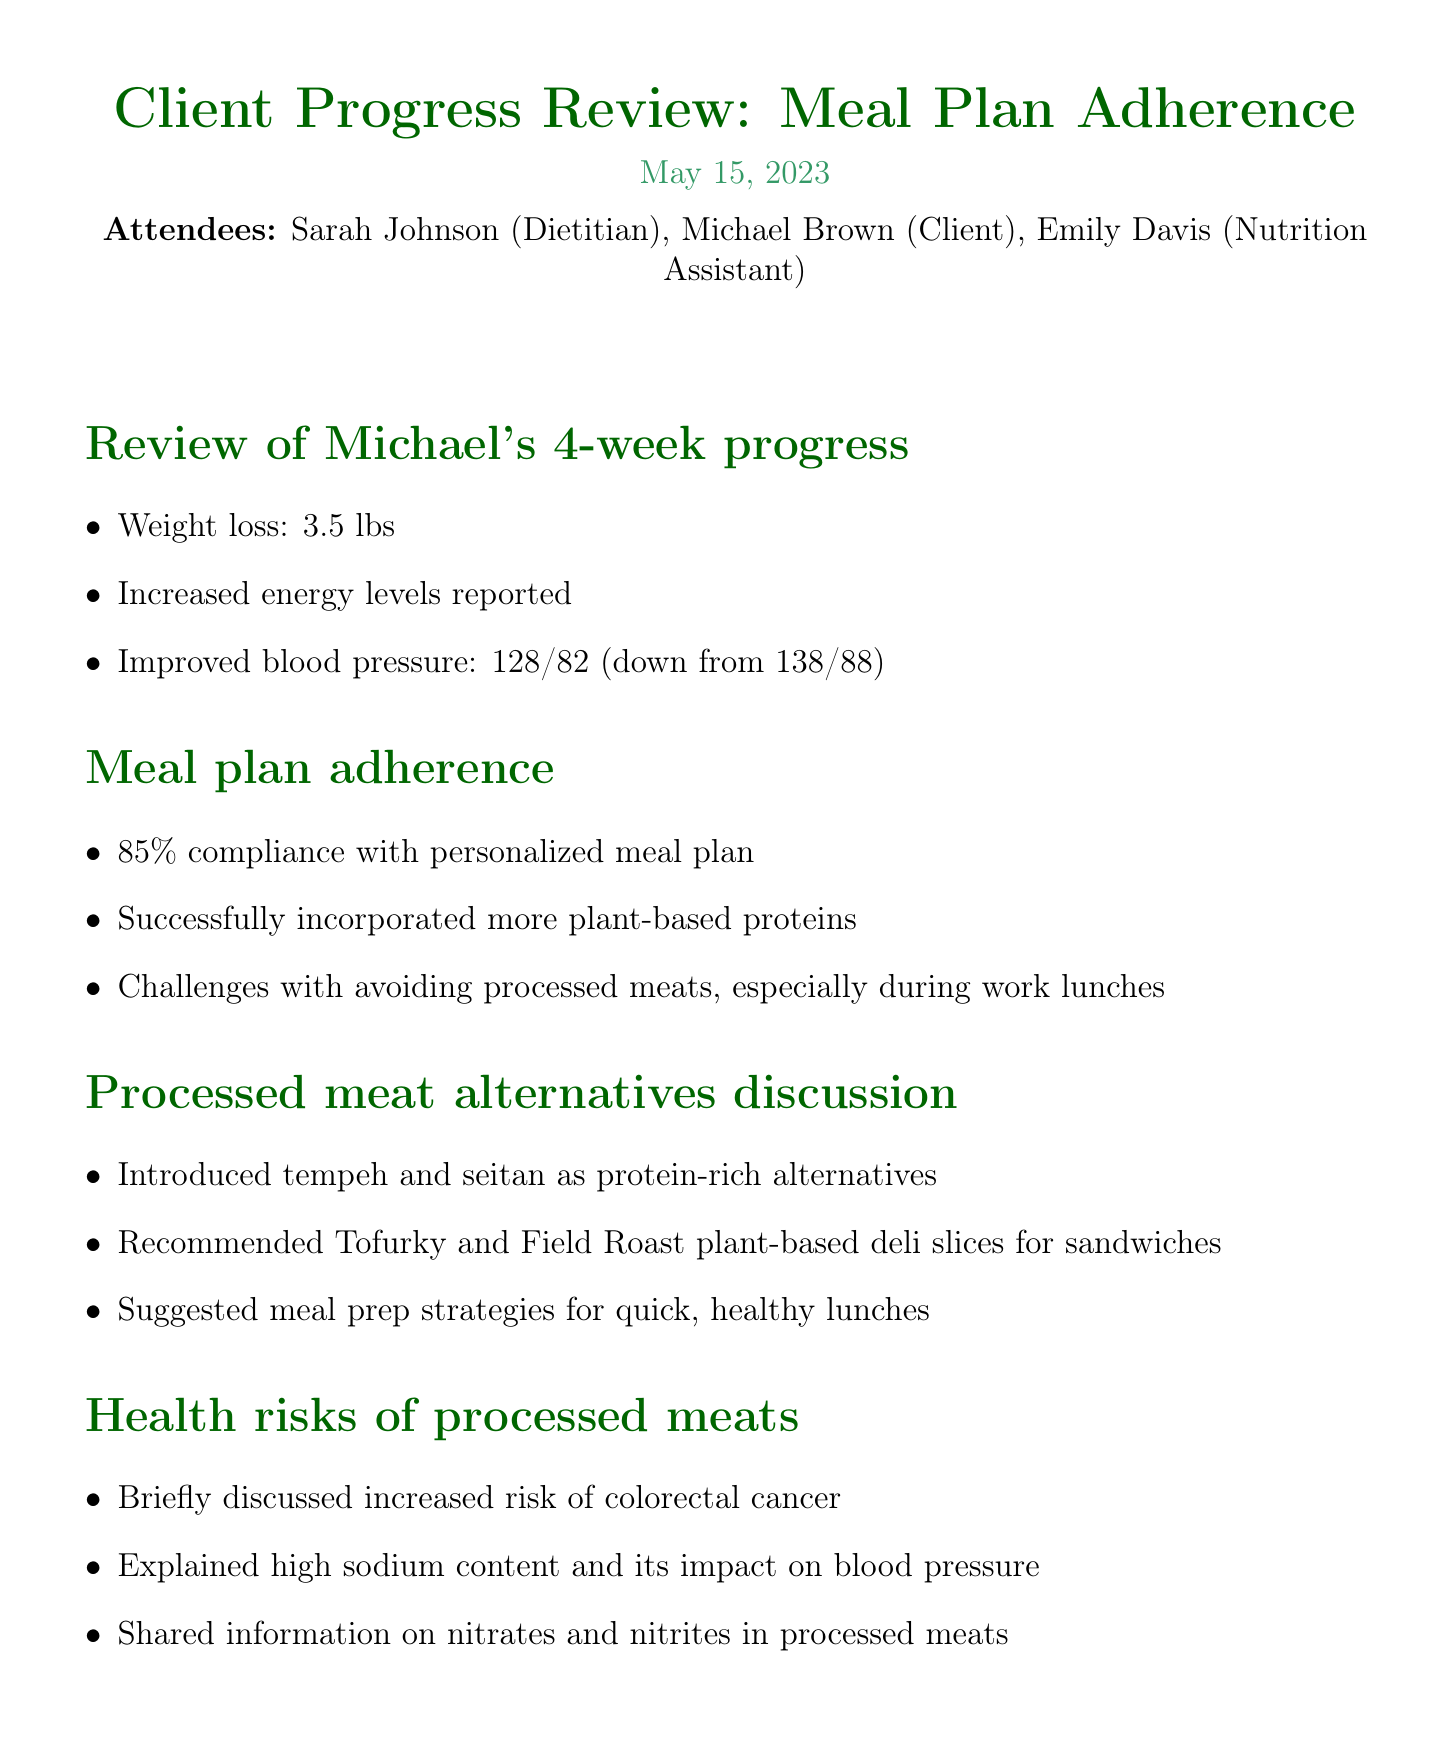What is the date of the meeting? The date of the meeting is mentioned in the document as May 15, 2023.
Answer: May 15, 2023 Who is the client discussed in the meeting? The client's name is mentioned among the attendees as Michael Brown.
Answer: Michael Brown What percentage of meal plan compliance did Michael achieve? The document states that Michael achieved an 85% compliance with the personalized meal plan.
Answer: 85% What health improvement did Michael report? The document lists an improvement in blood pressure from 138/88 to 128/82.
Answer: 128/82 What alternative was introduced for protein-rich meals? The meeting notes mention tempeh and seitan as introduced protein-rich alternatives.
Answer: Tempeh and seitan What is one of the action items for Michael? The document specifies that Michael is to try two new plant-based lunch recipes next week.
Answer: Two new plant-based lunch recipes Which health risk associated with processed meats was discussed? The document notes the increased risk of colorectal cancer as a discussed health risk.
Answer: Colorectal cancer When is the follow-up appointment scheduled? The follow-up appointment date is mentioned in the action items as June 12, 2023.
Answer: June 12, 2023 